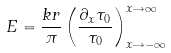Convert formula to latex. <formula><loc_0><loc_0><loc_500><loc_500>E = \frac { k r } { \pi } \left ( \frac { \partial _ { x } \tau _ { 0 } } { \tau _ { 0 } } \right ) _ { x \rightarrow - \infty } ^ { x \rightarrow \infty }</formula> 